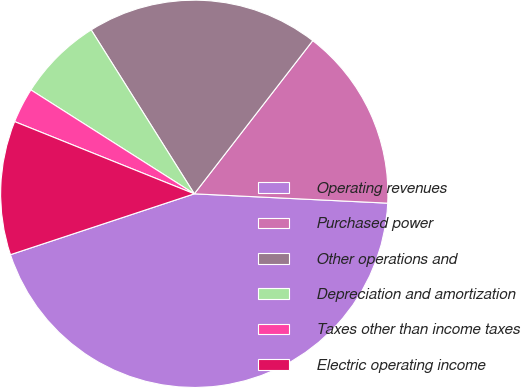Convert chart. <chart><loc_0><loc_0><loc_500><loc_500><pie_chart><fcel>Operating revenues<fcel>Purchased power<fcel>Other operations and<fcel>Depreciation and amortization<fcel>Taxes other than income taxes<fcel>Electric operating income<nl><fcel>44.14%<fcel>15.29%<fcel>19.41%<fcel>7.05%<fcel>2.93%<fcel>11.17%<nl></chart> 